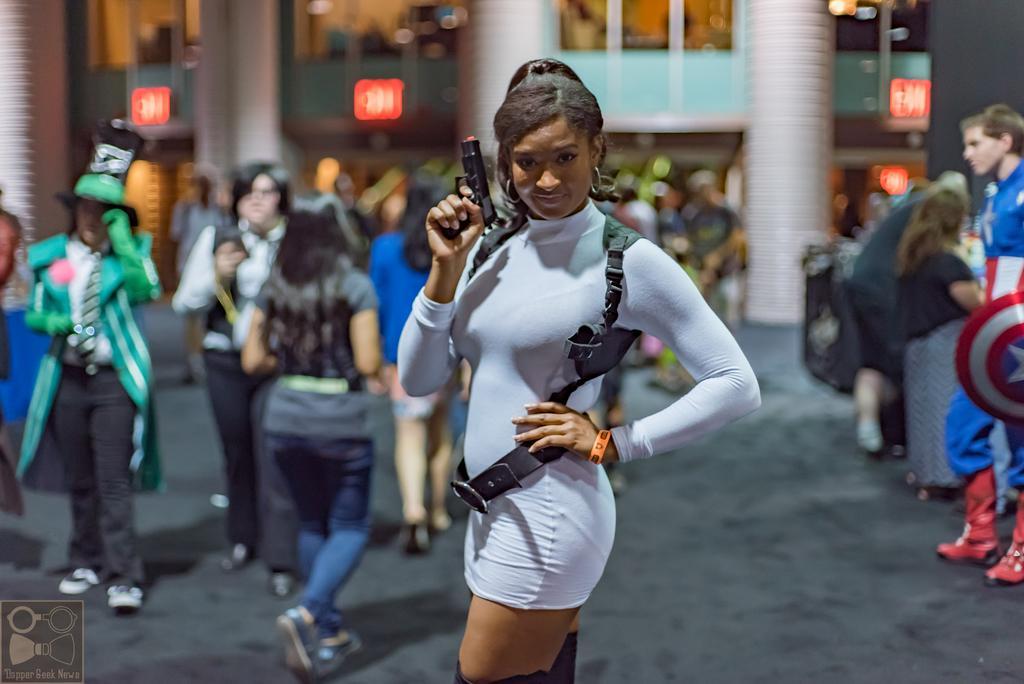How would you summarize this image in a sentence or two? In this image we can see a woman standing holding a gun. On the backside we can see a group of people on the ground. In that some are wearing the costumes. We can also see the sign boards and a building with pillars. 